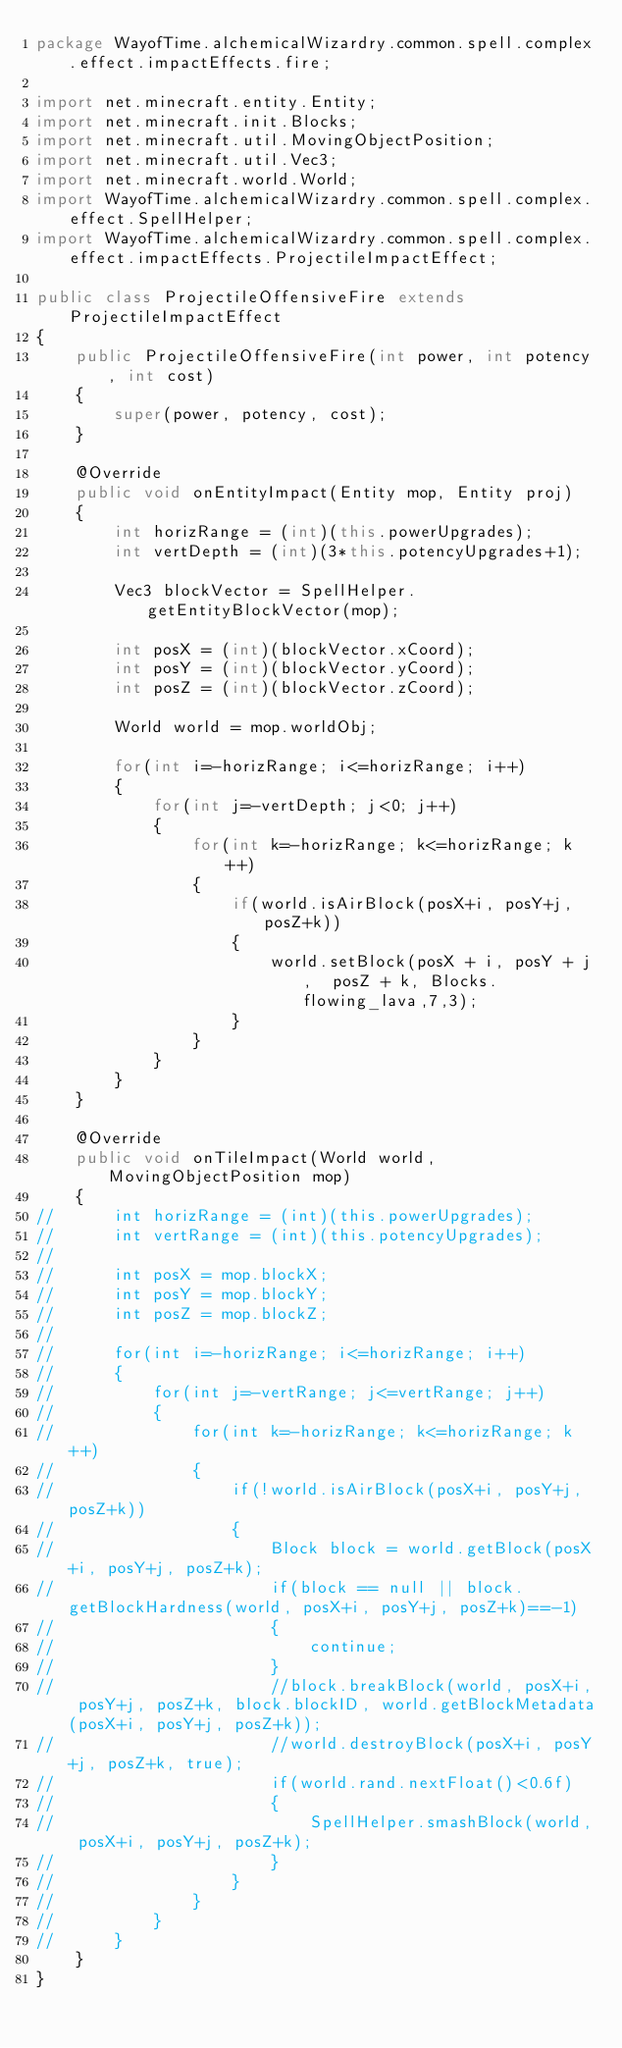Convert code to text. <code><loc_0><loc_0><loc_500><loc_500><_Java_>package WayofTime.alchemicalWizardry.common.spell.complex.effect.impactEffects.fire;

import net.minecraft.entity.Entity;
import net.minecraft.init.Blocks;
import net.minecraft.util.MovingObjectPosition;
import net.minecraft.util.Vec3;
import net.minecraft.world.World;
import WayofTime.alchemicalWizardry.common.spell.complex.effect.SpellHelper;
import WayofTime.alchemicalWizardry.common.spell.complex.effect.impactEffects.ProjectileImpactEffect;

public class ProjectileOffensiveFire extends ProjectileImpactEffect 
{
	public ProjectileOffensiveFire(int power, int potency, int cost) 
	{
		super(power, potency, cost);
	}

	@Override
	public void onEntityImpact(Entity mop, Entity proj) 
	{
		int horizRange = (int)(this.powerUpgrades);
		int vertDepth = (int)(3*this.potencyUpgrades+1);
		
		Vec3 blockVector = SpellHelper.getEntityBlockVector(mop);
		
		int posX = (int)(blockVector.xCoord);
		int posY = (int)(blockVector.yCoord);
		int posZ = (int)(blockVector.zCoord);
		
		World world = mop.worldObj;
		
		for(int i=-horizRange; i<=horizRange; i++)
		{
			for(int j=-vertDepth; j<0; j++)
			{
				for(int k=-horizRange; k<=horizRange; k++)
				{
					if(world.isAirBlock(posX+i, posY+j, posZ+k))
					{
						world.setBlock(posX + i, posY + j,  posZ + k, Blocks.flowing_lava,7,3);
					}
				}
			}
		}
	}

	@Override
	public void onTileImpact(World world, MovingObjectPosition mop) 
	{		
//		int horizRange = (int)(this.powerUpgrades);
//		int vertRange = (int)(this.potencyUpgrades);
//		
//		int posX = mop.blockX;
//		int posY = mop.blockY;
//		int posZ = mop.blockZ;
//		
//		for(int i=-horizRange; i<=horizRange; i++)
//		{
//			for(int j=-vertRange; j<=vertRange; j++)
//			{
//				for(int k=-horizRange; k<=horizRange; k++)
//				{
//					if(!world.isAirBlock(posX+i, posY+j, posZ+k))
//					{
//						Block block = world.getBlock(posX+i, posY+j, posZ+k);
//						if(block == null || block.getBlockHardness(world, posX+i, posY+j, posZ+k)==-1)
//						{
//							continue;
//						}
//						//block.breakBlock(world, posX+i, posY+j, posZ+k, block.blockID, world.getBlockMetadata(posX+i, posY+j, posZ+k));
//						//world.destroyBlock(posX+i, posY+j, posZ+k, true);
//						if(world.rand.nextFloat()<0.6f)
//						{
//							SpellHelper.smashBlock(world, posX+i, posY+j, posZ+k);
//						}
//					}
//				}
//			}
//		}
	}
}
</code> 